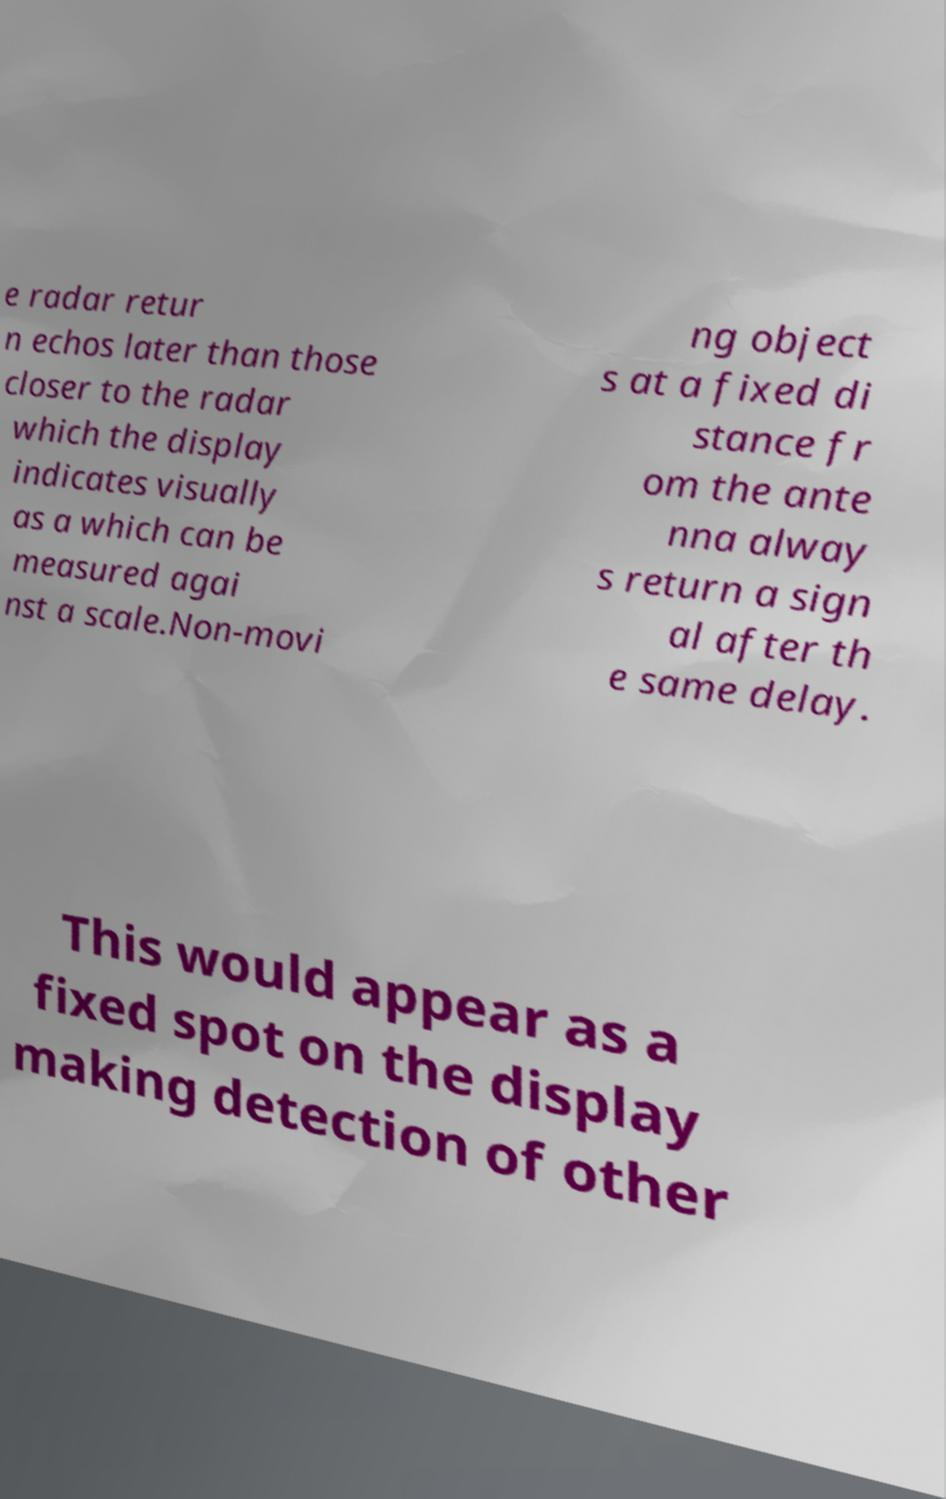Please identify and transcribe the text found in this image. e radar retur n echos later than those closer to the radar which the display indicates visually as a which can be measured agai nst a scale.Non-movi ng object s at a fixed di stance fr om the ante nna alway s return a sign al after th e same delay. This would appear as a fixed spot on the display making detection of other 